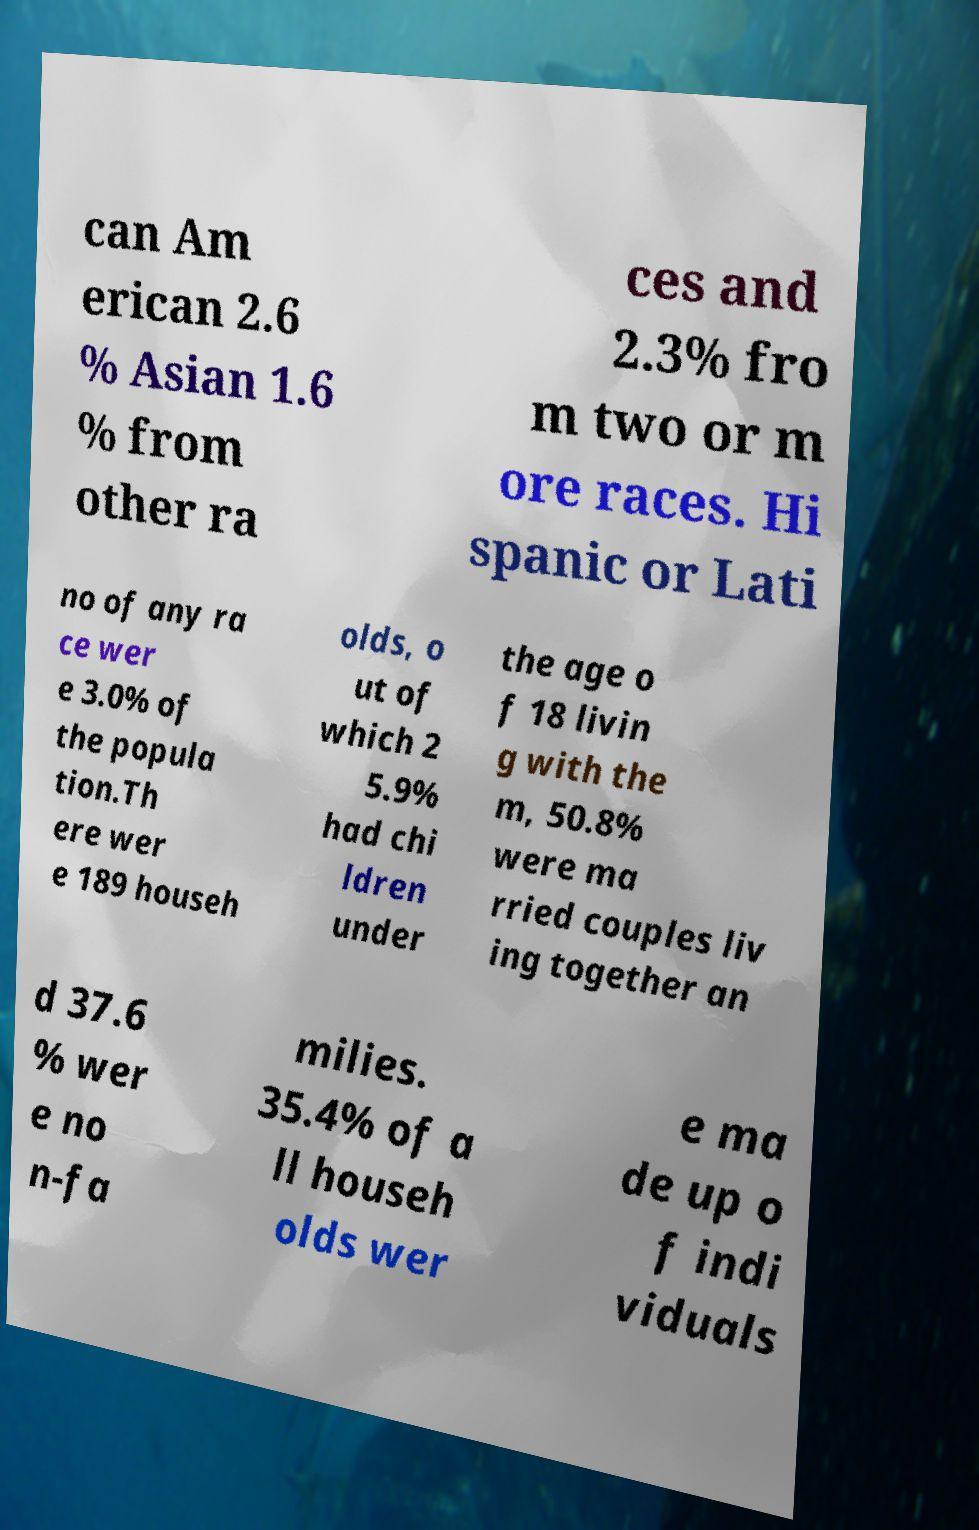Please identify and transcribe the text found in this image. can Am erican 2.6 % Asian 1.6 % from other ra ces and 2.3% fro m two or m ore races. Hi spanic or Lati no of any ra ce wer e 3.0% of the popula tion.Th ere wer e 189 househ olds, o ut of which 2 5.9% had chi ldren under the age o f 18 livin g with the m, 50.8% were ma rried couples liv ing together an d 37.6 % wer e no n-fa milies. 35.4% of a ll househ olds wer e ma de up o f indi viduals 